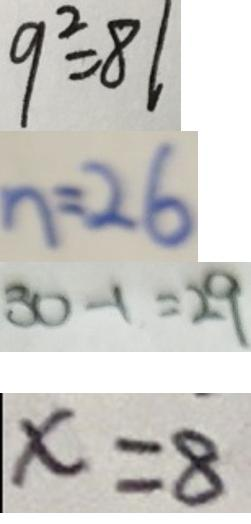<formula> <loc_0><loc_0><loc_500><loc_500>9 ^ { 2 } = 8 1 
 n = 2 6 
 3 0 - 1 = 2 9 
 x = 8</formula> 